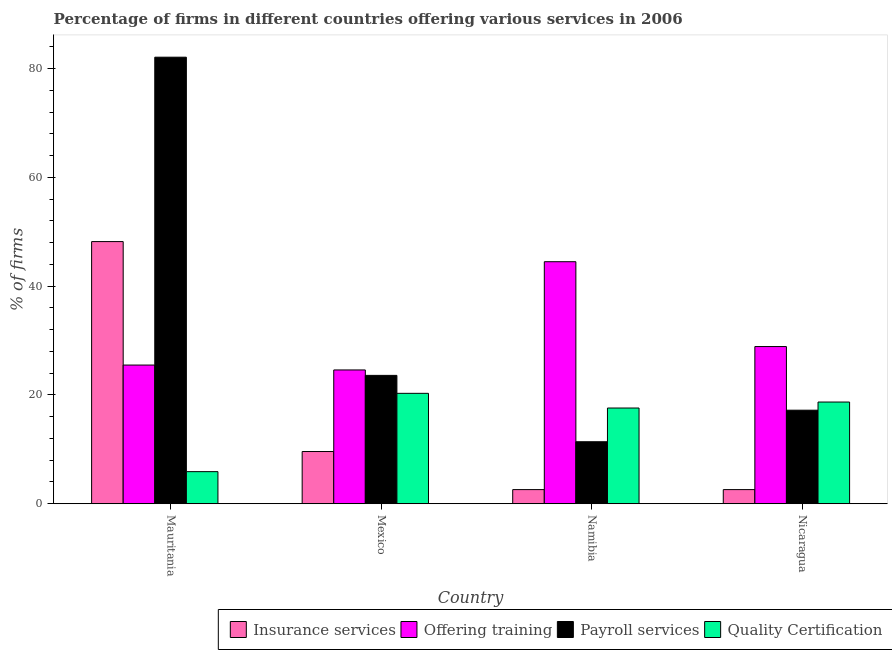How many different coloured bars are there?
Offer a terse response. 4. How many groups of bars are there?
Your answer should be very brief. 4. Are the number of bars per tick equal to the number of legend labels?
Give a very brief answer. Yes. Are the number of bars on each tick of the X-axis equal?
Your response must be concise. Yes. How many bars are there on the 3rd tick from the left?
Provide a succinct answer. 4. What is the label of the 1st group of bars from the left?
Provide a succinct answer. Mauritania. What is the percentage of firms offering quality certification in Mexico?
Provide a short and direct response. 20.3. Across all countries, what is the maximum percentage of firms offering payroll services?
Give a very brief answer. 82.1. Across all countries, what is the minimum percentage of firms offering training?
Your answer should be compact. 24.6. In which country was the percentage of firms offering training maximum?
Offer a very short reply. Namibia. What is the total percentage of firms offering training in the graph?
Make the answer very short. 123.5. What is the difference between the percentage of firms offering insurance services in Mauritania and that in Namibia?
Provide a short and direct response. 45.6. What is the difference between the percentage of firms offering insurance services in Mexico and the percentage of firms offering quality certification in Mauritania?
Keep it short and to the point. 3.7. What is the average percentage of firms offering training per country?
Your answer should be compact. 30.88. What is the difference between the percentage of firms offering payroll services and percentage of firms offering training in Mauritania?
Make the answer very short. 56.6. What is the ratio of the percentage of firms offering insurance services in Mauritania to that in Mexico?
Ensure brevity in your answer.  5.02. Is the percentage of firms offering payroll services in Mauritania less than that in Mexico?
Give a very brief answer. No. Is the difference between the percentage of firms offering training in Mexico and Namibia greater than the difference between the percentage of firms offering payroll services in Mexico and Namibia?
Your answer should be compact. No. What is the difference between the highest and the second highest percentage of firms offering insurance services?
Ensure brevity in your answer.  38.6. What is the difference between the highest and the lowest percentage of firms offering training?
Offer a terse response. 19.9. Is the sum of the percentage of firms offering quality certification in Namibia and Nicaragua greater than the maximum percentage of firms offering payroll services across all countries?
Provide a short and direct response. No. Is it the case that in every country, the sum of the percentage of firms offering payroll services and percentage of firms offering quality certification is greater than the sum of percentage of firms offering insurance services and percentage of firms offering training?
Provide a succinct answer. No. What does the 2nd bar from the left in Nicaragua represents?
Offer a very short reply. Offering training. What does the 3rd bar from the right in Nicaragua represents?
Make the answer very short. Offering training. Is it the case that in every country, the sum of the percentage of firms offering insurance services and percentage of firms offering training is greater than the percentage of firms offering payroll services?
Your answer should be very brief. No. How many countries are there in the graph?
Make the answer very short. 4. Does the graph contain any zero values?
Your response must be concise. No. Does the graph contain grids?
Give a very brief answer. No. Where does the legend appear in the graph?
Keep it short and to the point. Bottom right. How many legend labels are there?
Provide a succinct answer. 4. What is the title of the graph?
Make the answer very short. Percentage of firms in different countries offering various services in 2006. What is the label or title of the X-axis?
Your answer should be compact. Country. What is the label or title of the Y-axis?
Keep it short and to the point. % of firms. What is the % of firms of Insurance services in Mauritania?
Offer a terse response. 48.2. What is the % of firms of Payroll services in Mauritania?
Offer a very short reply. 82.1. What is the % of firms in Insurance services in Mexico?
Your answer should be very brief. 9.6. What is the % of firms in Offering training in Mexico?
Offer a terse response. 24.6. What is the % of firms in Payroll services in Mexico?
Provide a short and direct response. 23.6. What is the % of firms of Quality Certification in Mexico?
Your response must be concise. 20.3. What is the % of firms in Insurance services in Namibia?
Your response must be concise. 2.6. What is the % of firms in Offering training in Namibia?
Your answer should be compact. 44.5. What is the % of firms of Offering training in Nicaragua?
Your answer should be very brief. 28.9. What is the % of firms in Payroll services in Nicaragua?
Provide a succinct answer. 17.2. Across all countries, what is the maximum % of firms of Insurance services?
Keep it short and to the point. 48.2. Across all countries, what is the maximum % of firms in Offering training?
Give a very brief answer. 44.5. Across all countries, what is the maximum % of firms of Payroll services?
Offer a terse response. 82.1. Across all countries, what is the maximum % of firms in Quality Certification?
Ensure brevity in your answer.  20.3. Across all countries, what is the minimum % of firms in Insurance services?
Ensure brevity in your answer.  2.6. Across all countries, what is the minimum % of firms in Offering training?
Provide a succinct answer. 24.6. Across all countries, what is the minimum % of firms in Quality Certification?
Offer a very short reply. 5.9. What is the total % of firms of Offering training in the graph?
Keep it short and to the point. 123.5. What is the total % of firms of Payroll services in the graph?
Give a very brief answer. 134.3. What is the total % of firms of Quality Certification in the graph?
Offer a terse response. 62.5. What is the difference between the % of firms in Insurance services in Mauritania and that in Mexico?
Your response must be concise. 38.6. What is the difference between the % of firms in Payroll services in Mauritania and that in Mexico?
Provide a short and direct response. 58.5. What is the difference between the % of firms in Quality Certification in Mauritania and that in Mexico?
Your answer should be very brief. -14.4. What is the difference between the % of firms of Insurance services in Mauritania and that in Namibia?
Offer a very short reply. 45.6. What is the difference between the % of firms in Payroll services in Mauritania and that in Namibia?
Provide a short and direct response. 70.7. What is the difference between the % of firms of Quality Certification in Mauritania and that in Namibia?
Make the answer very short. -11.7. What is the difference between the % of firms of Insurance services in Mauritania and that in Nicaragua?
Keep it short and to the point. 45.6. What is the difference between the % of firms of Payroll services in Mauritania and that in Nicaragua?
Give a very brief answer. 64.9. What is the difference between the % of firms of Quality Certification in Mauritania and that in Nicaragua?
Keep it short and to the point. -12.8. What is the difference between the % of firms in Insurance services in Mexico and that in Namibia?
Your answer should be very brief. 7. What is the difference between the % of firms of Offering training in Mexico and that in Namibia?
Ensure brevity in your answer.  -19.9. What is the difference between the % of firms of Offering training in Mexico and that in Nicaragua?
Ensure brevity in your answer.  -4.3. What is the difference between the % of firms in Payroll services in Mexico and that in Nicaragua?
Give a very brief answer. 6.4. What is the difference between the % of firms of Insurance services in Namibia and that in Nicaragua?
Provide a succinct answer. 0. What is the difference between the % of firms in Offering training in Namibia and that in Nicaragua?
Your response must be concise. 15.6. What is the difference between the % of firms in Insurance services in Mauritania and the % of firms in Offering training in Mexico?
Provide a succinct answer. 23.6. What is the difference between the % of firms of Insurance services in Mauritania and the % of firms of Payroll services in Mexico?
Provide a succinct answer. 24.6. What is the difference between the % of firms of Insurance services in Mauritania and the % of firms of Quality Certification in Mexico?
Offer a very short reply. 27.9. What is the difference between the % of firms of Payroll services in Mauritania and the % of firms of Quality Certification in Mexico?
Give a very brief answer. 61.8. What is the difference between the % of firms in Insurance services in Mauritania and the % of firms in Payroll services in Namibia?
Make the answer very short. 36.8. What is the difference between the % of firms of Insurance services in Mauritania and the % of firms of Quality Certification in Namibia?
Offer a very short reply. 30.6. What is the difference between the % of firms in Offering training in Mauritania and the % of firms in Quality Certification in Namibia?
Provide a short and direct response. 7.9. What is the difference between the % of firms of Payroll services in Mauritania and the % of firms of Quality Certification in Namibia?
Your response must be concise. 64.5. What is the difference between the % of firms of Insurance services in Mauritania and the % of firms of Offering training in Nicaragua?
Offer a terse response. 19.3. What is the difference between the % of firms of Insurance services in Mauritania and the % of firms of Quality Certification in Nicaragua?
Ensure brevity in your answer.  29.5. What is the difference between the % of firms in Payroll services in Mauritania and the % of firms in Quality Certification in Nicaragua?
Ensure brevity in your answer.  63.4. What is the difference between the % of firms in Insurance services in Mexico and the % of firms in Offering training in Namibia?
Provide a short and direct response. -34.9. What is the difference between the % of firms of Insurance services in Mexico and the % of firms of Payroll services in Namibia?
Keep it short and to the point. -1.8. What is the difference between the % of firms of Payroll services in Mexico and the % of firms of Quality Certification in Namibia?
Ensure brevity in your answer.  6. What is the difference between the % of firms in Insurance services in Mexico and the % of firms in Offering training in Nicaragua?
Offer a very short reply. -19.3. What is the difference between the % of firms in Offering training in Mexico and the % of firms in Payroll services in Nicaragua?
Give a very brief answer. 7.4. What is the difference between the % of firms in Offering training in Mexico and the % of firms in Quality Certification in Nicaragua?
Make the answer very short. 5.9. What is the difference between the % of firms of Insurance services in Namibia and the % of firms of Offering training in Nicaragua?
Offer a very short reply. -26.3. What is the difference between the % of firms of Insurance services in Namibia and the % of firms of Payroll services in Nicaragua?
Your answer should be very brief. -14.6. What is the difference between the % of firms in Insurance services in Namibia and the % of firms in Quality Certification in Nicaragua?
Offer a very short reply. -16.1. What is the difference between the % of firms in Offering training in Namibia and the % of firms in Payroll services in Nicaragua?
Provide a succinct answer. 27.3. What is the difference between the % of firms of Offering training in Namibia and the % of firms of Quality Certification in Nicaragua?
Offer a terse response. 25.8. What is the difference between the % of firms in Payroll services in Namibia and the % of firms in Quality Certification in Nicaragua?
Give a very brief answer. -7.3. What is the average % of firms in Insurance services per country?
Ensure brevity in your answer.  15.75. What is the average % of firms of Offering training per country?
Offer a terse response. 30.88. What is the average % of firms of Payroll services per country?
Your answer should be very brief. 33.58. What is the average % of firms of Quality Certification per country?
Your answer should be compact. 15.62. What is the difference between the % of firms in Insurance services and % of firms in Offering training in Mauritania?
Provide a succinct answer. 22.7. What is the difference between the % of firms in Insurance services and % of firms in Payroll services in Mauritania?
Your response must be concise. -33.9. What is the difference between the % of firms in Insurance services and % of firms in Quality Certification in Mauritania?
Offer a very short reply. 42.3. What is the difference between the % of firms in Offering training and % of firms in Payroll services in Mauritania?
Make the answer very short. -56.6. What is the difference between the % of firms of Offering training and % of firms of Quality Certification in Mauritania?
Keep it short and to the point. 19.6. What is the difference between the % of firms in Payroll services and % of firms in Quality Certification in Mauritania?
Your answer should be very brief. 76.2. What is the difference between the % of firms of Insurance services and % of firms of Offering training in Mexico?
Offer a terse response. -15. What is the difference between the % of firms of Insurance services and % of firms of Payroll services in Mexico?
Keep it short and to the point. -14. What is the difference between the % of firms in Insurance services and % of firms in Quality Certification in Mexico?
Ensure brevity in your answer.  -10.7. What is the difference between the % of firms in Offering training and % of firms in Quality Certification in Mexico?
Offer a very short reply. 4.3. What is the difference between the % of firms in Payroll services and % of firms in Quality Certification in Mexico?
Your answer should be very brief. 3.3. What is the difference between the % of firms of Insurance services and % of firms of Offering training in Namibia?
Give a very brief answer. -41.9. What is the difference between the % of firms of Insurance services and % of firms of Payroll services in Namibia?
Your response must be concise. -8.8. What is the difference between the % of firms in Insurance services and % of firms in Quality Certification in Namibia?
Provide a succinct answer. -15. What is the difference between the % of firms of Offering training and % of firms of Payroll services in Namibia?
Provide a succinct answer. 33.1. What is the difference between the % of firms in Offering training and % of firms in Quality Certification in Namibia?
Your response must be concise. 26.9. What is the difference between the % of firms in Payroll services and % of firms in Quality Certification in Namibia?
Provide a short and direct response. -6.2. What is the difference between the % of firms of Insurance services and % of firms of Offering training in Nicaragua?
Keep it short and to the point. -26.3. What is the difference between the % of firms in Insurance services and % of firms in Payroll services in Nicaragua?
Ensure brevity in your answer.  -14.6. What is the difference between the % of firms in Insurance services and % of firms in Quality Certification in Nicaragua?
Your answer should be very brief. -16.1. What is the difference between the % of firms of Offering training and % of firms of Payroll services in Nicaragua?
Give a very brief answer. 11.7. What is the difference between the % of firms in Offering training and % of firms in Quality Certification in Nicaragua?
Offer a terse response. 10.2. What is the difference between the % of firms of Payroll services and % of firms of Quality Certification in Nicaragua?
Keep it short and to the point. -1.5. What is the ratio of the % of firms in Insurance services in Mauritania to that in Mexico?
Keep it short and to the point. 5.02. What is the ratio of the % of firms in Offering training in Mauritania to that in Mexico?
Your answer should be very brief. 1.04. What is the ratio of the % of firms in Payroll services in Mauritania to that in Mexico?
Keep it short and to the point. 3.48. What is the ratio of the % of firms in Quality Certification in Mauritania to that in Mexico?
Your response must be concise. 0.29. What is the ratio of the % of firms in Insurance services in Mauritania to that in Namibia?
Make the answer very short. 18.54. What is the ratio of the % of firms of Offering training in Mauritania to that in Namibia?
Provide a succinct answer. 0.57. What is the ratio of the % of firms in Payroll services in Mauritania to that in Namibia?
Your answer should be compact. 7.2. What is the ratio of the % of firms of Quality Certification in Mauritania to that in Namibia?
Your response must be concise. 0.34. What is the ratio of the % of firms in Insurance services in Mauritania to that in Nicaragua?
Keep it short and to the point. 18.54. What is the ratio of the % of firms in Offering training in Mauritania to that in Nicaragua?
Make the answer very short. 0.88. What is the ratio of the % of firms of Payroll services in Mauritania to that in Nicaragua?
Ensure brevity in your answer.  4.77. What is the ratio of the % of firms in Quality Certification in Mauritania to that in Nicaragua?
Ensure brevity in your answer.  0.32. What is the ratio of the % of firms of Insurance services in Mexico to that in Namibia?
Keep it short and to the point. 3.69. What is the ratio of the % of firms of Offering training in Mexico to that in Namibia?
Provide a short and direct response. 0.55. What is the ratio of the % of firms in Payroll services in Mexico to that in Namibia?
Your answer should be very brief. 2.07. What is the ratio of the % of firms in Quality Certification in Mexico to that in Namibia?
Provide a succinct answer. 1.15. What is the ratio of the % of firms in Insurance services in Mexico to that in Nicaragua?
Keep it short and to the point. 3.69. What is the ratio of the % of firms in Offering training in Mexico to that in Nicaragua?
Provide a short and direct response. 0.85. What is the ratio of the % of firms in Payroll services in Mexico to that in Nicaragua?
Offer a terse response. 1.37. What is the ratio of the % of firms in Quality Certification in Mexico to that in Nicaragua?
Make the answer very short. 1.09. What is the ratio of the % of firms in Insurance services in Namibia to that in Nicaragua?
Offer a terse response. 1. What is the ratio of the % of firms in Offering training in Namibia to that in Nicaragua?
Provide a short and direct response. 1.54. What is the ratio of the % of firms in Payroll services in Namibia to that in Nicaragua?
Make the answer very short. 0.66. What is the ratio of the % of firms of Quality Certification in Namibia to that in Nicaragua?
Provide a succinct answer. 0.94. What is the difference between the highest and the second highest % of firms of Insurance services?
Offer a terse response. 38.6. What is the difference between the highest and the second highest % of firms in Offering training?
Your response must be concise. 15.6. What is the difference between the highest and the second highest % of firms in Payroll services?
Your answer should be very brief. 58.5. What is the difference between the highest and the lowest % of firms in Insurance services?
Your answer should be compact. 45.6. What is the difference between the highest and the lowest % of firms in Offering training?
Offer a very short reply. 19.9. What is the difference between the highest and the lowest % of firms of Payroll services?
Offer a terse response. 70.7. What is the difference between the highest and the lowest % of firms of Quality Certification?
Keep it short and to the point. 14.4. 